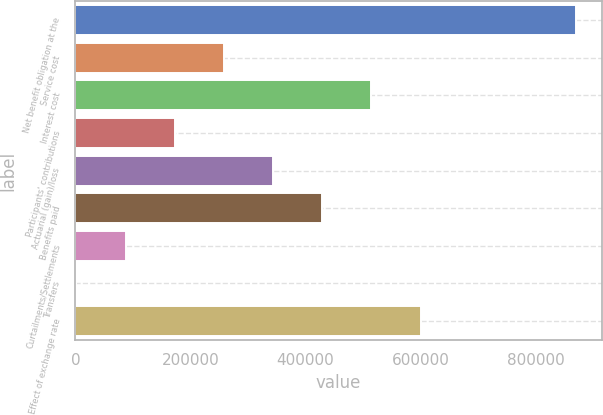Convert chart. <chart><loc_0><loc_0><loc_500><loc_500><bar_chart><fcel>Net benefit obligation at the<fcel>Service cost<fcel>Interest cost<fcel>Participants' contributions<fcel>Actuarial (gain)/loss<fcel>Benefits paid<fcel>Curtailments/Settlements<fcel>Transfers<fcel>Effect of exchange rate<nl><fcel>870561<fcel>258117<fcel>514365<fcel>172700<fcel>343533<fcel>428949<fcel>87284.2<fcel>1868<fcel>599781<nl></chart> 